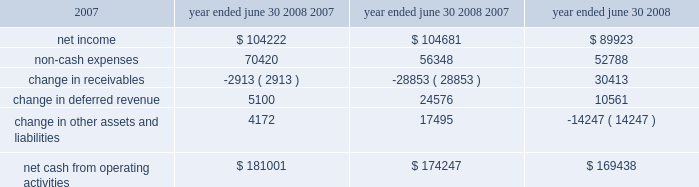L iquidity and capital resources we have historically generated positive cash flow from operations and have generally used funds generated from operations and short-term borrowings on our revolving credit facility to meet capital requirements .
We expect this trend to continue in the future .
The company's cash and cash equivalents decreased to $ 65565 at june 30 , 2008 from $ 88617 at june 30 , 2007 .
The table summarizes net cash from operating activities in the statement of cash flows : year ended june 30 cash provided by operations increased $ 6754 to $ 181001 for the fiscal year ended june 30 , 2008 as compared to $ 174247 for the fiscal year ended june 30 , 2007 .
This increase is primarily attributable to an increase in expenses that do not have a corresponding cash outflow , such as depreciation and amortization , as a percentage of total net income .
Cash used in investing activities for the fiscal year ended june 2008 was $ 102148 and includes payments for acquisitions of $ 48109 , plus $ 1215 in contingent consideration paid on prior years 2019 acquisitions .
During fiscal 2007 , payments for acquisitions totaled $ 34006 , plus $ 5301 paid on earn-outs and other acquisition adjustments .
Capital expenditures for fiscal 2008 were $ 31105 compared to $ 34202 for fiscal 2007 .
Cash used for software development in fiscal 2008 was $ 23736 compared to $ 20743 during the prior year .
Net cash used in financing activities for the current fiscal year was $ 101905 and includes the repurchase of 4200 shares of our common stock for $ 100996 , the payment of dividends of $ 24683 and $ 429 net repayment on our revolving credit facilities .
Cash used in financing activities was partially offset by proceeds of $ 20394 from the exercise of stock options and the sale of common stock and $ 3809 excess tax benefits from stock option exercises .
During fiscal 2007 , net cash used in financing activities included the repurchase of our common stock for $ 98413 and the payment of dividends of $ 21685 .
As in the current year , cash used in fiscal 2007 was partially offset by proceeds from the exercise of stock options and the sale of common stock of $ 29212 , $ 4640 excess tax benefits from stock option exercises and $ 19388 net borrowings on revolving credit facilities .
At june 30 , 2008 , the company had negative working capital of $ 11418 ; however , the largest component of current liabilities was deferred revenue of $ 212375 .
The cash outlay necessary to provide the services related to these deferred revenues is significantly less than this recorded balance .
Therefore , we do not anticipate any liquidity problems to result from this condition .
U.s .
Financial markets and many of the largest u.s .
Financial institutions have recently been shaken by negative developments in the home mortgage industry and the mortgage markets , and particularly the markets for subprime mortgage-backed securities .
While we believe it is too early to predict what effect , if any , these developments may have , we have not experienced any significant issues with our current collec- tion efforts , and we believe that any future impact to our liquidity would be minimized by our access to available lines of credit .
2008 2007 2006 .

By how much was the net cash from fiscal year ending in june 2007 below the three year average of net cash from operating activities? 
Rationale: calculate the average by adding all the years' net cash and divide by 3 , then subtract the 2007 total from that number .
Computations: (((169438 + (181001 + 174247)) / 3) - 174247)
Answer: 648.33333. 